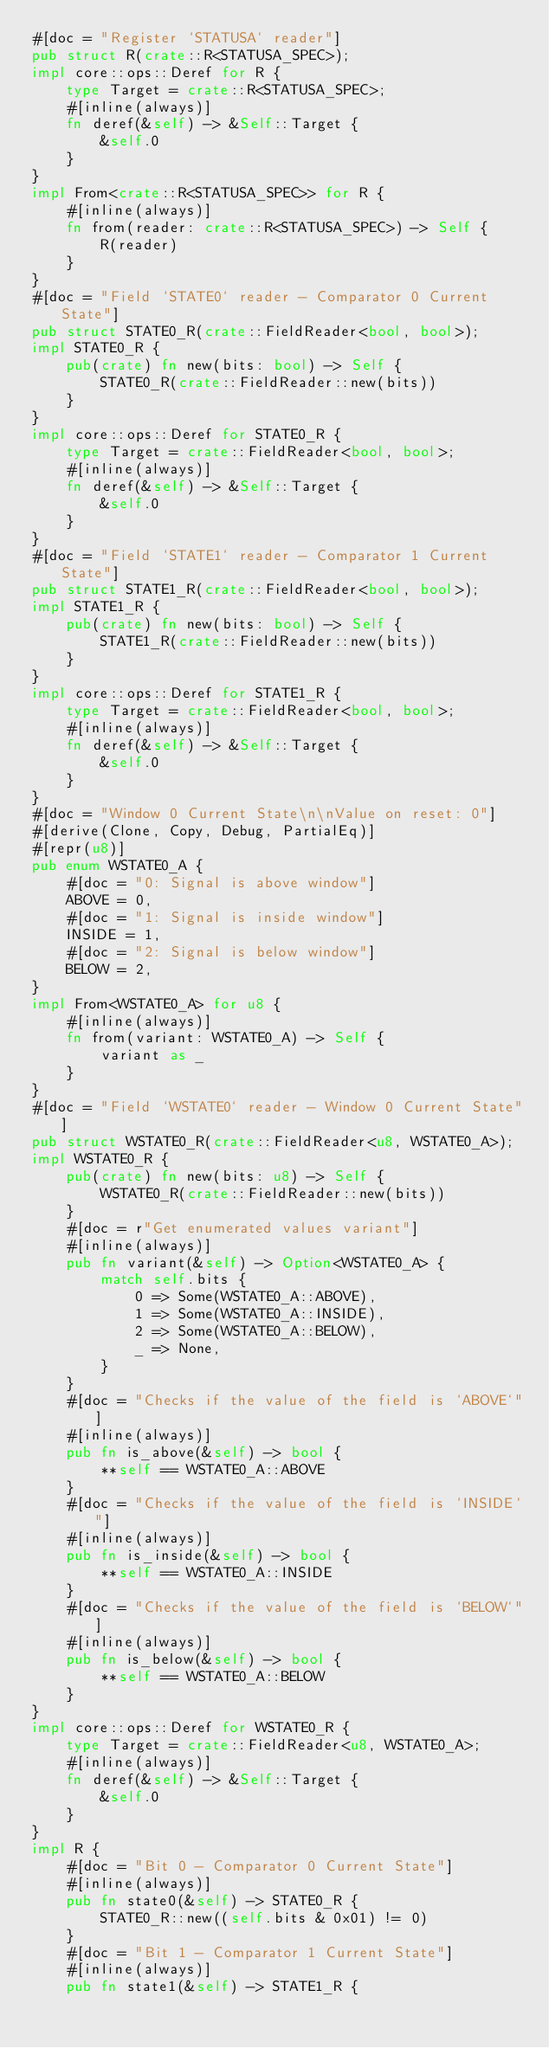<code> <loc_0><loc_0><loc_500><loc_500><_Rust_>#[doc = "Register `STATUSA` reader"]
pub struct R(crate::R<STATUSA_SPEC>);
impl core::ops::Deref for R {
    type Target = crate::R<STATUSA_SPEC>;
    #[inline(always)]
    fn deref(&self) -> &Self::Target {
        &self.0
    }
}
impl From<crate::R<STATUSA_SPEC>> for R {
    #[inline(always)]
    fn from(reader: crate::R<STATUSA_SPEC>) -> Self {
        R(reader)
    }
}
#[doc = "Field `STATE0` reader - Comparator 0 Current State"]
pub struct STATE0_R(crate::FieldReader<bool, bool>);
impl STATE0_R {
    pub(crate) fn new(bits: bool) -> Self {
        STATE0_R(crate::FieldReader::new(bits))
    }
}
impl core::ops::Deref for STATE0_R {
    type Target = crate::FieldReader<bool, bool>;
    #[inline(always)]
    fn deref(&self) -> &Self::Target {
        &self.0
    }
}
#[doc = "Field `STATE1` reader - Comparator 1 Current State"]
pub struct STATE1_R(crate::FieldReader<bool, bool>);
impl STATE1_R {
    pub(crate) fn new(bits: bool) -> Self {
        STATE1_R(crate::FieldReader::new(bits))
    }
}
impl core::ops::Deref for STATE1_R {
    type Target = crate::FieldReader<bool, bool>;
    #[inline(always)]
    fn deref(&self) -> &Self::Target {
        &self.0
    }
}
#[doc = "Window 0 Current State\n\nValue on reset: 0"]
#[derive(Clone, Copy, Debug, PartialEq)]
#[repr(u8)]
pub enum WSTATE0_A {
    #[doc = "0: Signal is above window"]
    ABOVE = 0,
    #[doc = "1: Signal is inside window"]
    INSIDE = 1,
    #[doc = "2: Signal is below window"]
    BELOW = 2,
}
impl From<WSTATE0_A> for u8 {
    #[inline(always)]
    fn from(variant: WSTATE0_A) -> Self {
        variant as _
    }
}
#[doc = "Field `WSTATE0` reader - Window 0 Current State"]
pub struct WSTATE0_R(crate::FieldReader<u8, WSTATE0_A>);
impl WSTATE0_R {
    pub(crate) fn new(bits: u8) -> Self {
        WSTATE0_R(crate::FieldReader::new(bits))
    }
    #[doc = r"Get enumerated values variant"]
    #[inline(always)]
    pub fn variant(&self) -> Option<WSTATE0_A> {
        match self.bits {
            0 => Some(WSTATE0_A::ABOVE),
            1 => Some(WSTATE0_A::INSIDE),
            2 => Some(WSTATE0_A::BELOW),
            _ => None,
        }
    }
    #[doc = "Checks if the value of the field is `ABOVE`"]
    #[inline(always)]
    pub fn is_above(&self) -> bool {
        **self == WSTATE0_A::ABOVE
    }
    #[doc = "Checks if the value of the field is `INSIDE`"]
    #[inline(always)]
    pub fn is_inside(&self) -> bool {
        **self == WSTATE0_A::INSIDE
    }
    #[doc = "Checks if the value of the field is `BELOW`"]
    #[inline(always)]
    pub fn is_below(&self) -> bool {
        **self == WSTATE0_A::BELOW
    }
}
impl core::ops::Deref for WSTATE0_R {
    type Target = crate::FieldReader<u8, WSTATE0_A>;
    #[inline(always)]
    fn deref(&self) -> &Self::Target {
        &self.0
    }
}
impl R {
    #[doc = "Bit 0 - Comparator 0 Current State"]
    #[inline(always)]
    pub fn state0(&self) -> STATE0_R {
        STATE0_R::new((self.bits & 0x01) != 0)
    }
    #[doc = "Bit 1 - Comparator 1 Current State"]
    #[inline(always)]
    pub fn state1(&self) -> STATE1_R {</code> 